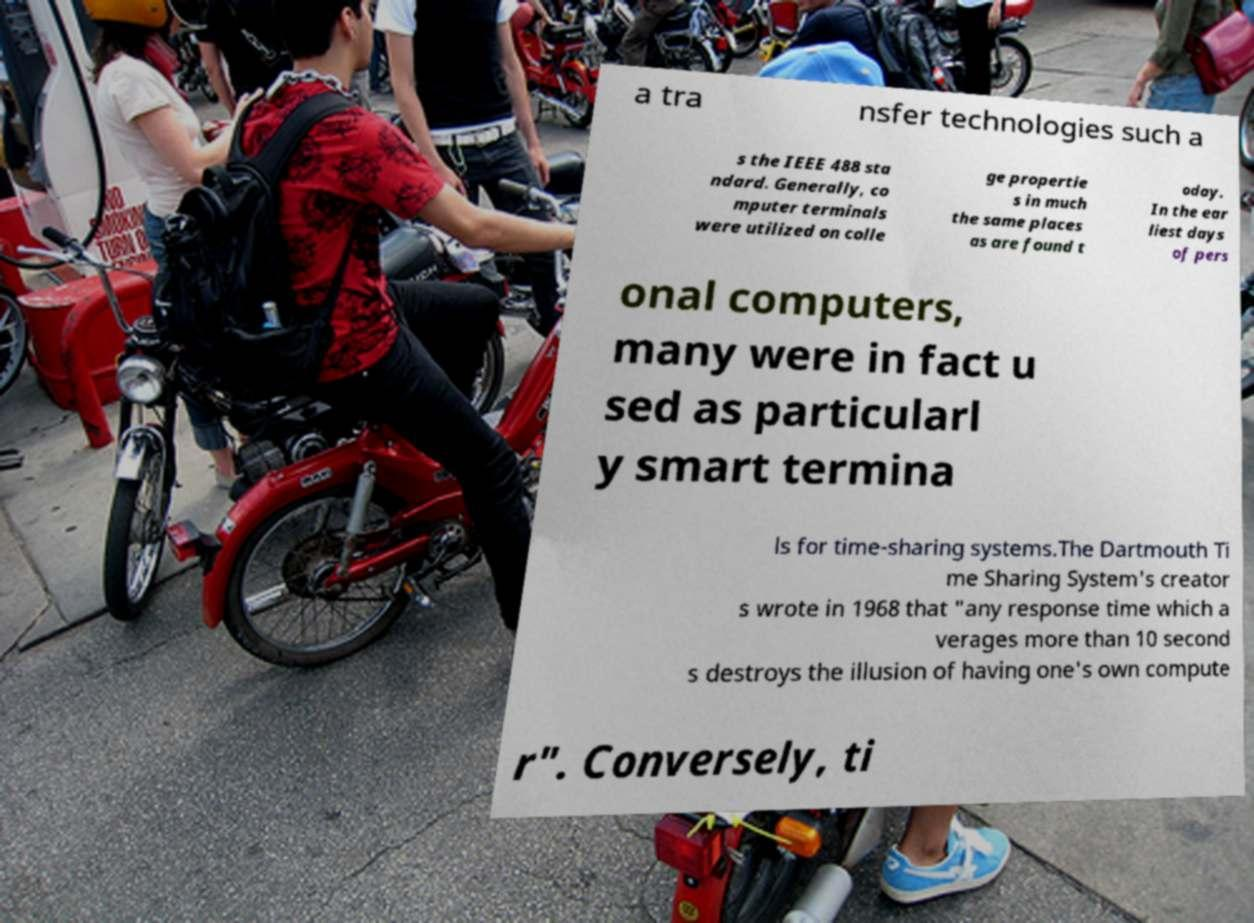Could you assist in decoding the text presented in this image and type it out clearly? a tra nsfer technologies such a s the IEEE 488 sta ndard. Generally, co mputer terminals were utilized on colle ge propertie s in much the same places as are found t oday. In the ear liest days of pers onal computers, many were in fact u sed as particularl y smart termina ls for time-sharing systems.The Dartmouth Ti me Sharing System's creator s wrote in 1968 that "any response time which a verages more than 10 second s destroys the illusion of having one's own compute r". Conversely, ti 